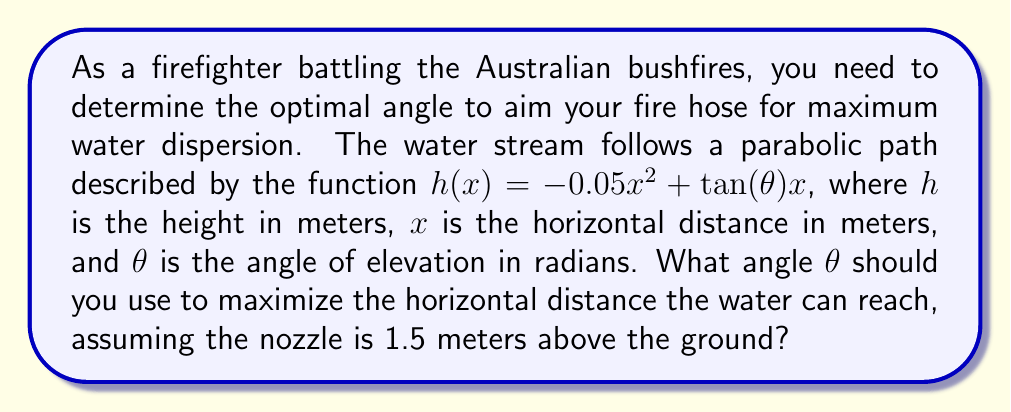What is the answer to this math problem? To solve this problem, we'll follow these steps:

1) The water stream hits the ground when $h(x) = 1.5$ (since the nozzle is 1.5m above ground). So we need to solve:

   $1.5 = -0.05x^2 + \tan(\theta)x$

2) Rearranging this equation:

   $0.05x^2 - \tan(\theta)x + 1.5 = 0$

3) This is a quadratic equation. For maximum horizontal distance, we want this equation to have exactly one solution (tangent point). This occurs when the discriminant is zero. The discriminant of $ax^2 + bx + c = 0$ is $b^2 - 4ac$.

4) In our case, $a = 0.05$, $b = -\tan(\theta)$, and $c = 1.5$. Setting the discriminant to zero:

   $\tan^2(\theta) - 4(0.05)(1.5) = 0$

5) Simplifying:

   $\tan^2(\theta) = 0.3$

6) Taking the square root of both sides:

   $\tan(\theta) = \sqrt{0.3} \approx 0.5477$

7) Taking the inverse tangent:

   $\theta = \arctan(\sqrt{0.3}) \approx 0.5033$ radians

8) Converting to degrees:

   $\theta \approx 28.84°$

Therefore, the optimal angle for maximum horizontal distance is approximately 28.84°.
Answer: $\theta \approx 28.84°$ or $0.5033$ radians 